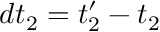<formula> <loc_0><loc_0><loc_500><loc_500>d t _ { 2 } = t _ { 2 } ^ { \prime } - t _ { 2 }</formula> 